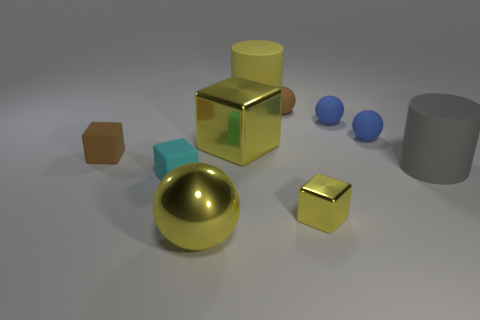The small ball on the left side of the shiny thing that is right of the large yellow block is what color?
Your answer should be very brief. Brown. What is the material of the large yellow object that is the same shape as the tiny yellow metal object?
Keep it short and to the point. Metal. What number of matte cylinders have the same size as the metallic sphere?
Make the answer very short. 2. There is a yellow ball that is made of the same material as the small yellow block; what is its size?
Offer a terse response. Large. How many blue rubber things have the same shape as the large gray matte object?
Provide a succinct answer. 0. What number of small blue things are there?
Give a very brief answer. 2. Is the shape of the small brown matte thing right of the tiny brown cube the same as  the big yellow matte object?
Offer a very short reply. No. There is another cylinder that is the same size as the yellow cylinder; what is its material?
Offer a very short reply. Rubber. Are there any large red cylinders made of the same material as the yellow cylinder?
Make the answer very short. No. Does the gray matte thing have the same shape as the tiny brown rubber thing that is on the left side of the yellow rubber cylinder?
Your response must be concise. No. 